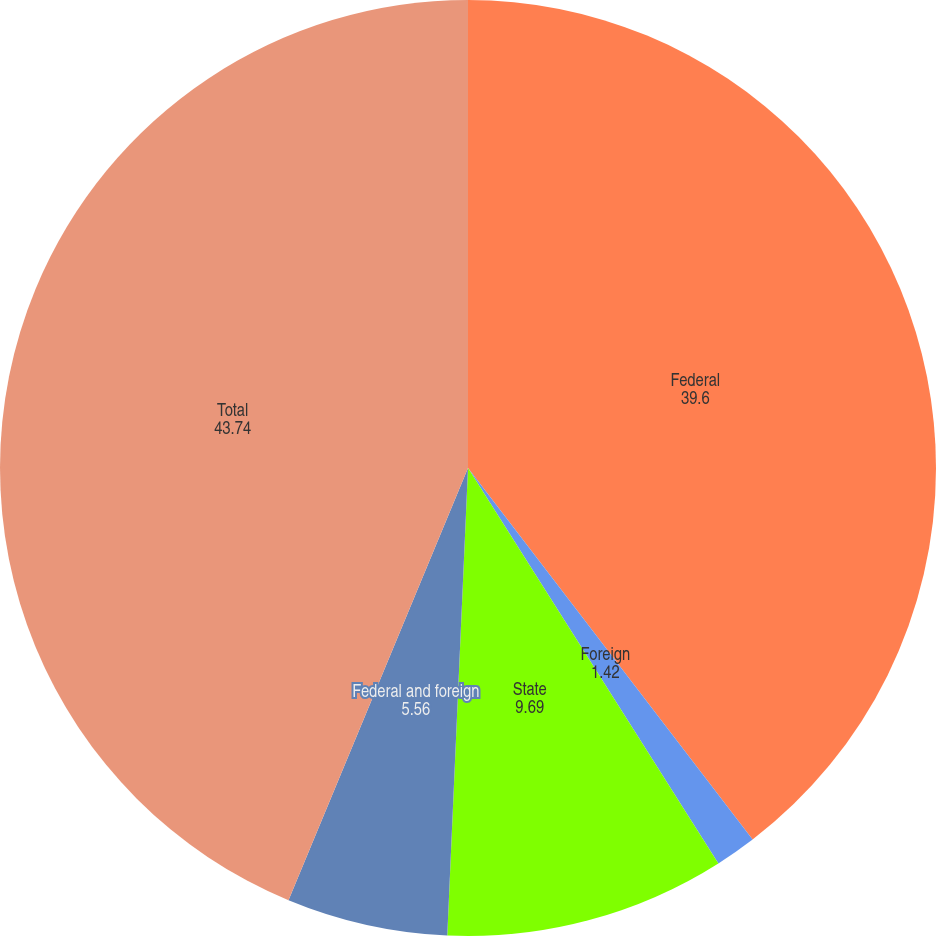Convert chart to OTSL. <chart><loc_0><loc_0><loc_500><loc_500><pie_chart><fcel>Federal<fcel>Foreign<fcel>State<fcel>Federal and foreign<fcel>Total<nl><fcel>39.6%<fcel>1.42%<fcel>9.69%<fcel>5.56%<fcel>43.74%<nl></chart> 